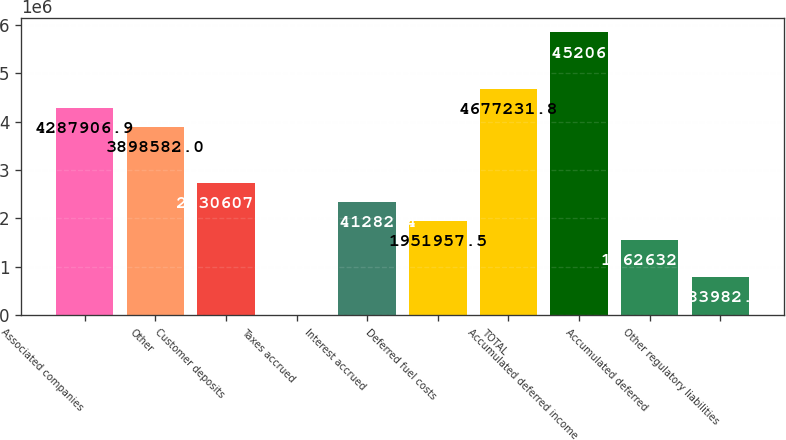Convert chart. <chart><loc_0><loc_0><loc_500><loc_500><bar_chart><fcel>Associated companies<fcel>Other<fcel>Customer deposits<fcel>Taxes accrued<fcel>Interest accrued<fcel>Deferred fuel costs<fcel>TOTAL<fcel>Accumulated deferred income<fcel>Accumulated deferred<fcel>Other regulatory liabilities<nl><fcel>4.28791e+06<fcel>3.89858e+06<fcel>2.73061e+06<fcel>5333<fcel>2.34128e+06<fcel>1.95196e+06<fcel>4.67723e+06<fcel>5.84521e+06<fcel>1.56263e+06<fcel>783983<nl></chart> 